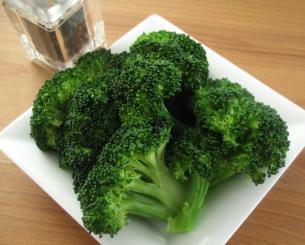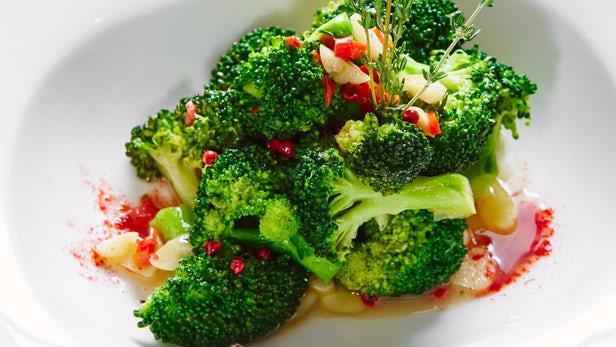The first image is the image on the left, the second image is the image on the right. Analyze the images presented: Is the assertion "The left and right image contains a total two white plates with broccoli." valid? Answer yes or no. Yes. The first image is the image on the left, the second image is the image on the right. Considering the images on both sides, is "Each image shows broccoli florets in a white container, and one image shows broccoli florets in an oblong-shaped bowl." valid? Answer yes or no. Yes. 